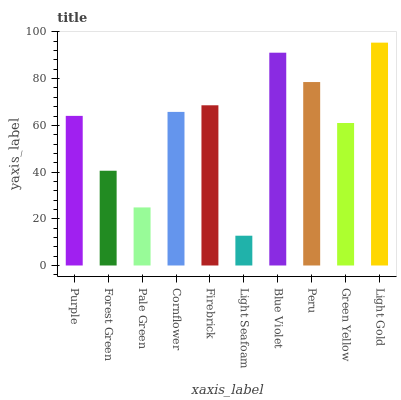Is Forest Green the minimum?
Answer yes or no. No. Is Forest Green the maximum?
Answer yes or no. No. Is Purple greater than Forest Green?
Answer yes or no. Yes. Is Forest Green less than Purple?
Answer yes or no. Yes. Is Forest Green greater than Purple?
Answer yes or no. No. Is Purple less than Forest Green?
Answer yes or no. No. Is Cornflower the high median?
Answer yes or no. Yes. Is Purple the low median?
Answer yes or no. Yes. Is Peru the high median?
Answer yes or no. No. Is Cornflower the low median?
Answer yes or no. No. 